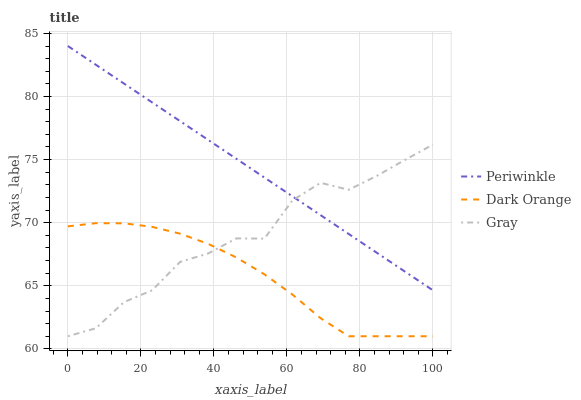Does Dark Orange have the minimum area under the curve?
Answer yes or no. Yes. Does Periwinkle have the maximum area under the curve?
Answer yes or no. Yes. Does Gray have the minimum area under the curve?
Answer yes or no. No. Does Gray have the maximum area under the curve?
Answer yes or no. No. Is Periwinkle the smoothest?
Answer yes or no. Yes. Is Gray the roughest?
Answer yes or no. Yes. Is Gray the smoothest?
Answer yes or no. No. Is Periwinkle the roughest?
Answer yes or no. No. Does Periwinkle have the lowest value?
Answer yes or no. No. Does Gray have the highest value?
Answer yes or no. No. Is Dark Orange less than Periwinkle?
Answer yes or no. Yes. Is Periwinkle greater than Dark Orange?
Answer yes or no. Yes. Does Dark Orange intersect Periwinkle?
Answer yes or no. No. 